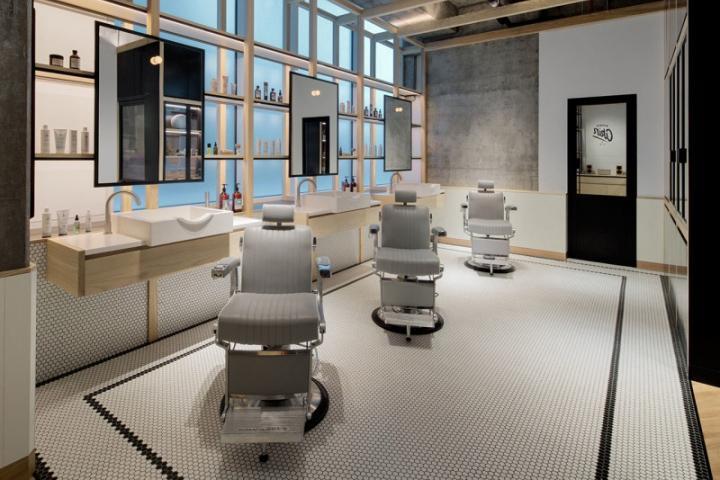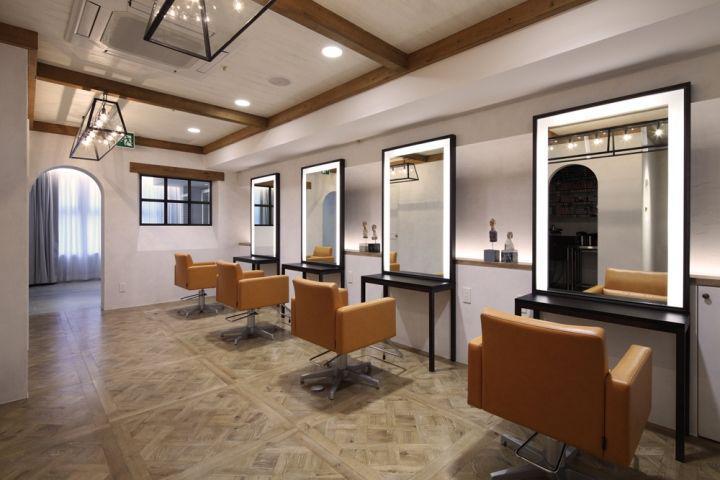The first image is the image on the left, the second image is the image on the right. For the images displayed, is the sentence "The chairs on the right side are white and black." factually correct? Answer yes or no. No. 